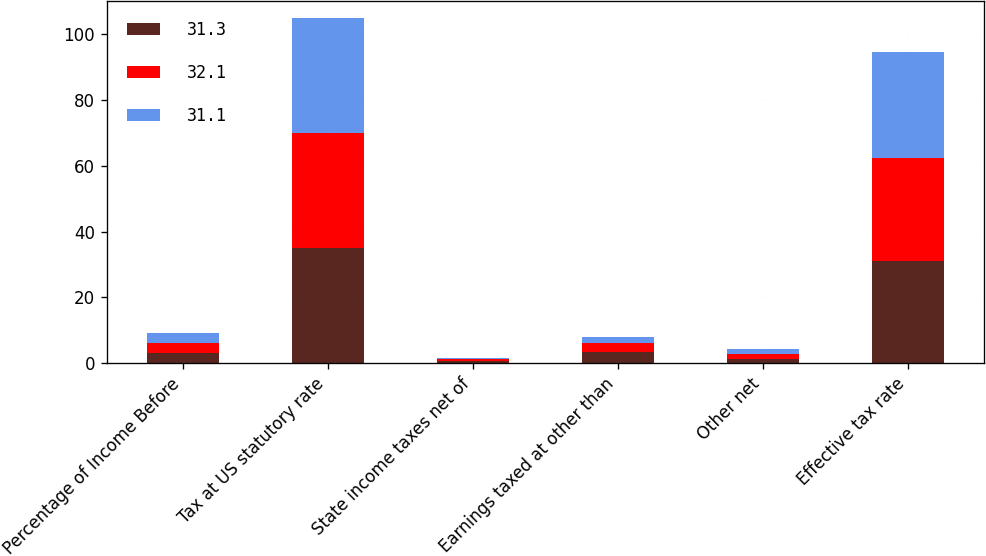Convert chart. <chart><loc_0><loc_0><loc_500><loc_500><stacked_bar_chart><ecel><fcel>Percentage of Income Before<fcel>Tax at US statutory rate<fcel>State income taxes net of<fcel>Earnings taxed at other than<fcel>Other net<fcel>Effective tax rate<nl><fcel>31.3<fcel>3<fcel>35<fcel>0.6<fcel>3.2<fcel>1.3<fcel>31.1<nl><fcel>32.1<fcel>3<fcel>35<fcel>0.6<fcel>3<fcel>1.3<fcel>31.3<nl><fcel>31.1<fcel>3<fcel>35<fcel>0.4<fcel>1.7<fcel>1.6<fcel>32.1<nl></chart> 